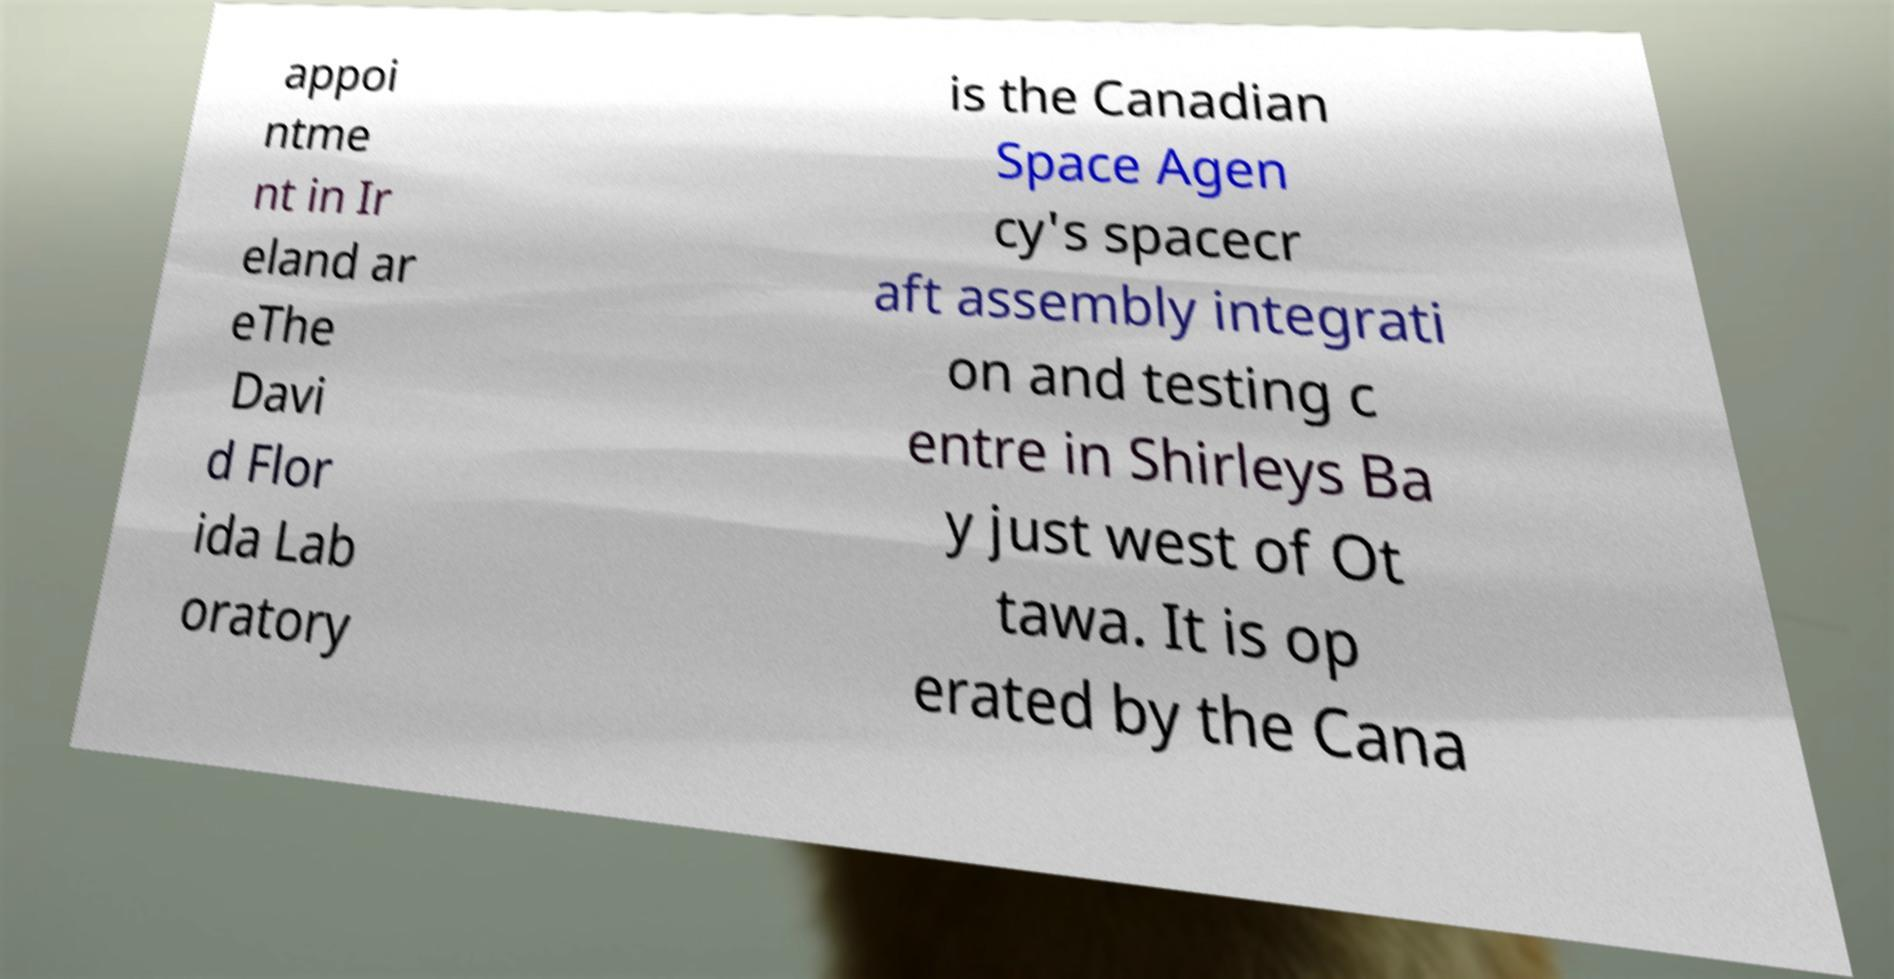Could you assist in decoding the text presented in this image and type it out clearly? appoi ntme nt in Ir eland ar eThe Davi d Flor ida Lab oratory is the Canadian Space Agen cy's spacecr aft assembly integrati on and testing c entre in Shirleys Ba y just west of Ot tawa. It is op erated by the Cana 